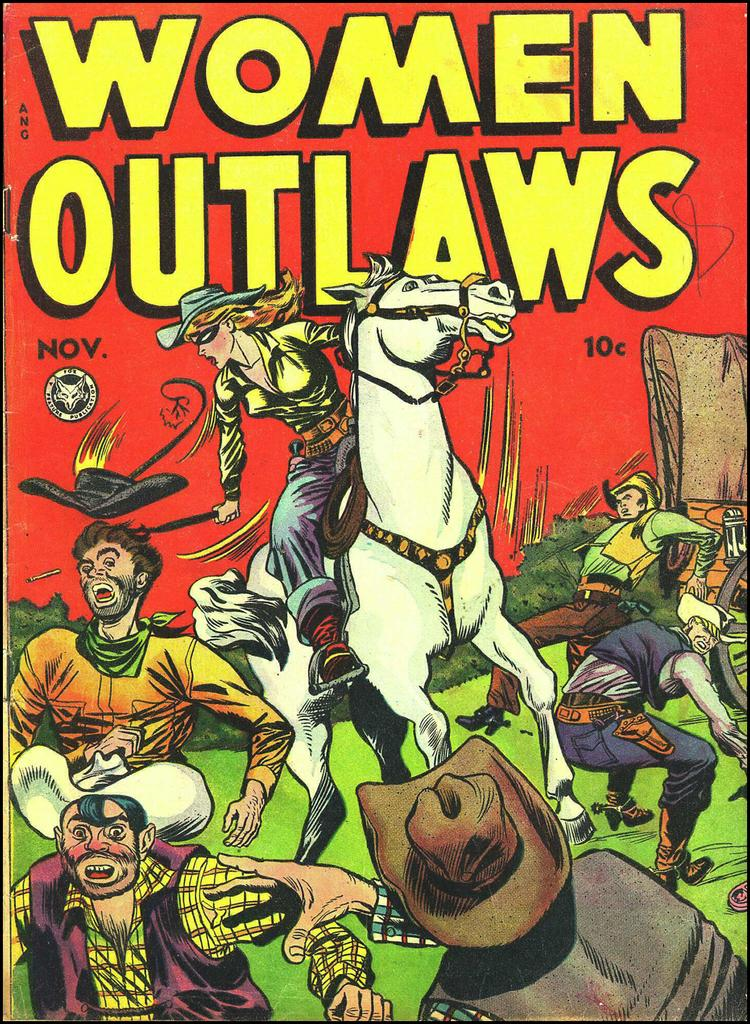<image>
Share a concise interpretation of the image provided. a comic book that says women outlaws on it 